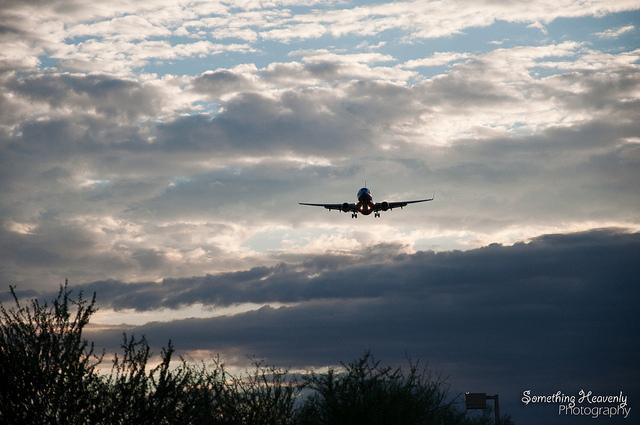How many wheels are visible on the plane?
Give a very brief answer. 4. 